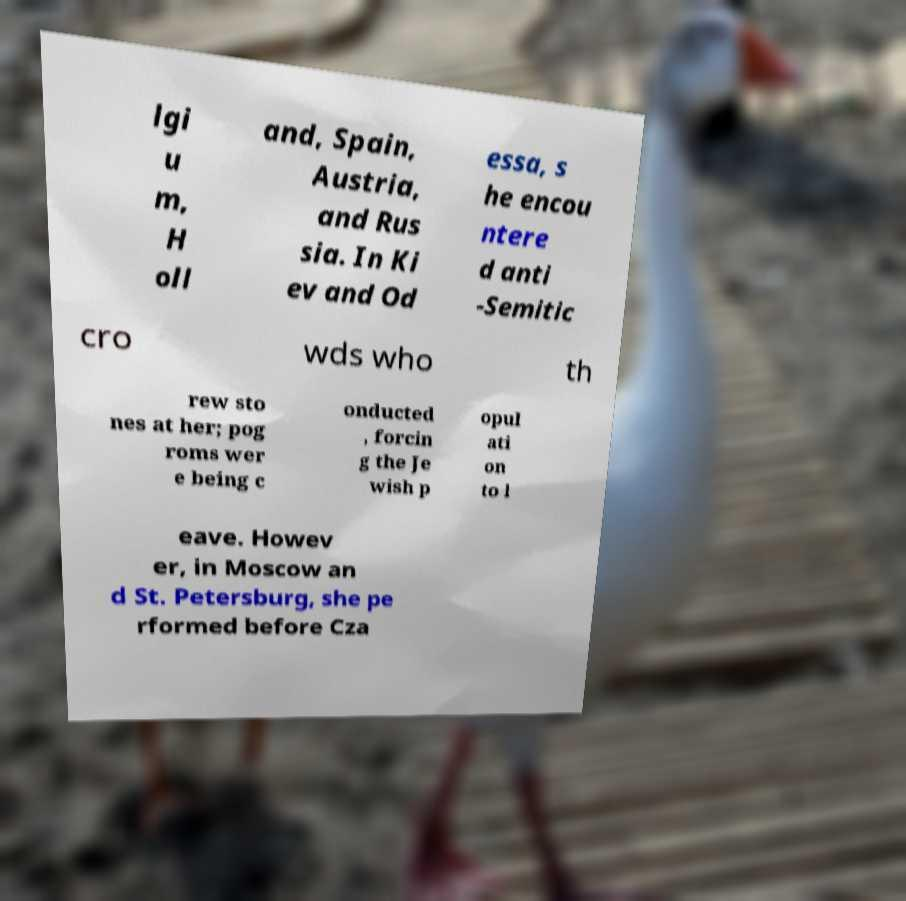I need the written content from this picture converted into text. Can you do that? lgi u m, H oll and, Spain, Austria, and Rus sia. In Ki ev and Od essa, s he encou ntere d anti -Semitic cro wds who th rew sto nes at her; pog roms wer e being c onducted , forcin g the Je wish p opul ati on to l eave. Howev er, in Moscow an d St. Petersburg, she pe rformed before Cza 